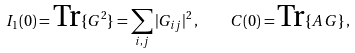<formula> <loc_0><loc_0><loc_500><loc_500>I _ { 1 } ( 0 ) = \text {Tr} \{ G ^ { 2 } \} = \sum _ { i , j } | G _ { i j } | ^ { 2 } \, , \quad C ( 0 ) = \text {Tr} \{ A \, G \} \, ,</formula> 